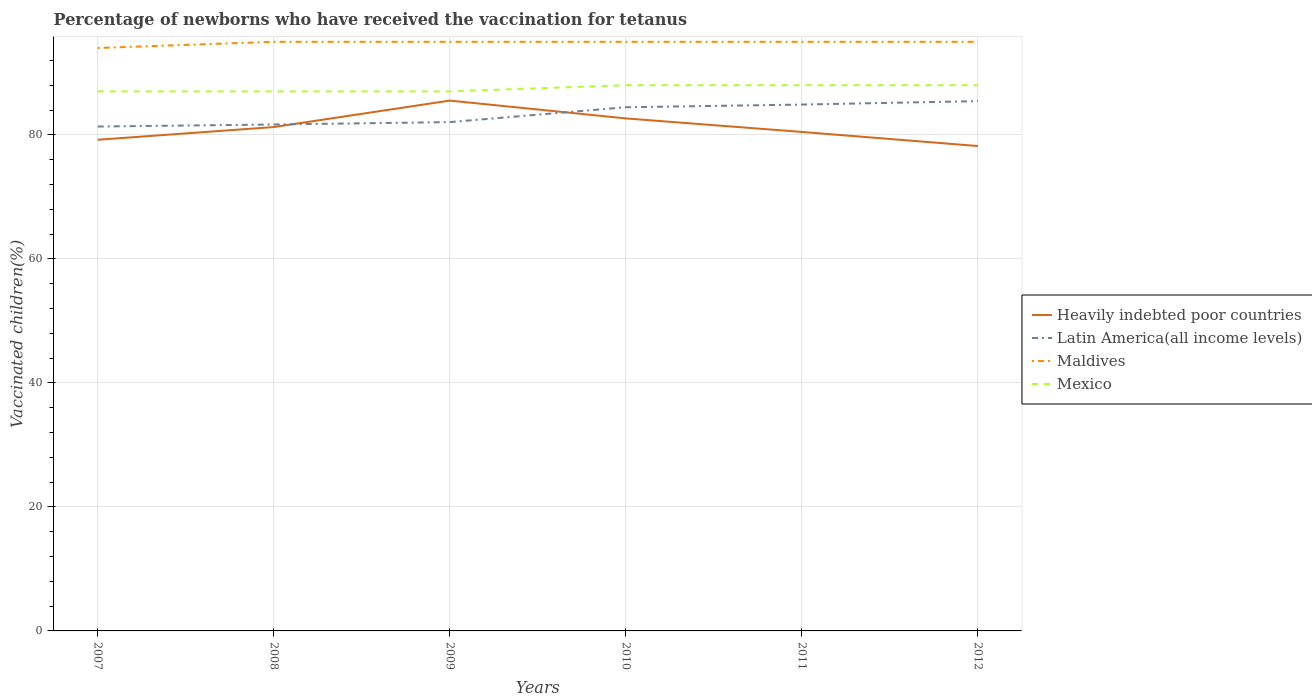Is the number of lines equal to the number of legend labels?
Provide a succinct answer. Yes. Across all years, what is the maximum percentage of vaccinated children in Latin America(all income levels)?
Your answer should be very brief. 81.33. In which year was the percentage of vaccinated children in Maldives maximum?
Make the answer very short. 2007. What is the total percentage of vaccinated children in Latin America(all income levels) in the graph?
Provide a succinct answer. -3.54. What is the difference between the highest and the second highest percentage of vaccinated children in Mexico?
Give a very brief answer. 1. How many lines are there?
Provide a short and direct response. 4. What is the difference between two consecutive major ticks on the Y-axis?
Make the answer very short. 20. Are the values on the major ticks of Y-axis written in scientific E-notation?
Ensure brevity in your answer.  No. Does the graph contain grids?
Offer a terse response. Yes. Where does the legend appear in the graph?
Ensure brevity in your answer.  Center right. How many legend labels are there?
Offer a terse response. 4. What is the title of the graph?
Make the answer very short. Percentage of newborns who have received the vaccination for tetanus. What is the label or title of the Y-axis?
Make the answer very short. Vaccinated children(%). What is the Vaccinated children(%) of Heavily indebted poor countries in 2007?
Your answer should be compact. 79.2. What is the Vaccinated children(%) in Latin America(all income levels) in 2007?
Ensure brevity in your answer.  81.33. What is the Vaccinated children(%) of Maldives in 2007?
Ensure brevity in your answer.  94. What is the Vaccinated children(%) in Mexico in 2007?
Your answer should be very brief. 87. What is the Vaccinated children(%) in Heavily indebted poor countries in 2008?
Your answer should be compact. 81.25. What is the Vaccinated children(%) of Latin America(all income levels) in 2008?
Make the answer very short. 81.66. What is the Vaccinated children(%) of Heavily indebted poor countries in 2009?
Give a very brief answer. 85.52. What is the Vaccinated children(%) in Latin America(all income levels) in 2009?
Your answer should be very brief. 82.05. What is the Vaccinated children(%) in Maldives in 2009?
Offer a very short reply. 95. What is the Vaccinated children(%) of Mexico in 2009?
Keep it short and to the point. 87. What is the Vaccinated children(%) in Heavily indebted poor countries in 2010?
Your answer should be compact. 82.64. What is the Vaccinated children(%) of Latin America(all income levels) in 2010?
Offer a very short reply. 84.45. What is the Vaccinated children(%) in Mexico in 2010?
Provide a succinct answer. 88. What is the Vaccinated children(%) of Heavily indebted poor countries in 2011?
Your answer should be very brief. 80.46. What is the Vaccinated children(%) in Latin America(all income levels) in 2011?
Offer a very short reply. 84.88. What is the Vaccinated children(%) in Mexico in 2011?
Your answer should be compact. 88. What is the Vaccinated children(%) in Heavily indebted poor countries in 2012?
Provide a short and direct response. 78.19. What is the Vaccinated children(%) in Latin America(all income levels) in 2012?
Your answer should be very brief. 85.43. What is the Vaccinated children(%) of Maldives in 2012?
Your response must be concise. 95. What is the Vaccinated children(%) of Mexico in 2012?
Ensure brevity in your answer.  88. Across all years, what is the maximum Vaccinated children(%) of Heavily indebted poor countries?
Ensure brevity in your answer.  85.52. Across all years, what is the maximum Vaccinated children(%) in Latin America(all income levels)?
Give a very brief answer. 85.43. Across all years, what is the maximum Vaccinated children(%) of Maldives?
Your answer should be compact. 95. Across all years, what is the maximum Vaccinated children(%) in Mexico?
Ensure brevity in your answer.  88. Across all years, what is the minimum Vaccinated children(%) in Heavily indebted poor countries?
Keep it short and to the point. 78.19. Across all years, what is the minimum Vaccinated children(%) in Latin America(all income levels)?
Offer a very short reply. 81.33. Across all years, what is the minimum Vaccinated children(%) of Maldives?
Make the answer very short. 94. What is the total Vaccinated children(%) of Heavily indebted poor countries in the graph?
Make the answer very short. 487.26. What is the total Vaccinated children(%) of Latin America(all income levels) in the graph?
Keep it short and to the point. 499.8. What is the total Vaccinated children(%) of Maldives in the graph?
Keep it short and to the point. 569. What is the total Vaccinated children(%) of Mexico in the graph?
Give a very brief answer. 525. What is the difference between the Vaccinated children(%) in Heavily indebted poor countries in 2007 and that in 2008?
Make the answer very short. -2.05. What is the difference between the Vaccinated children(%) of Latin America(all income levels) in 2007 and that in 2008?
Your response must be concise. -0.33. What is the difference between the Vaccinated children(%) in Maldives in 2007 and that in 2008?
Your answer should be compact. -1. What is the difference between the Vaccinated children(%) in Mexico in 2007 and that in 2008?
Give a very brief answer. 0. What is the difference between the Vaccinated children(%) of Heavily indebted poor countries in 2007 and that in 2009?
Offer a terse response. -6.32. What is the difference between the Vaccinated children(%) in Latin America(all income levels) in 2007 and that in 2009?
Give a very brief answer. -0.72. What is the difference between the Vaccinated children(%) in Heavily indebted poor countries in 2007 and that in 2010?
Keep it short and to the point. -3.44. What is the difference between the Vaccinated children(%) of Latin America(all income levels) in 2007 and that in 2010?
Give a very brief answer. -3.11. What is the difference between the Vaccinated children(%) of Maldives in 2007 and that in 2010?
Offer a terse response. -1. What is the difference between the Vaccinated children(%) of Heavily indebted poor countries in 2007 and that in 2011?
Your answer should be very brief. -1.26. What is the difference between the Vaccinated children(%) of Latin America(all income levels) in 2007 and that in 2011?
Your answer should be very brief. -3.54. What is the difference between the Vaccinated children(%) of Heavily indebted poor countries in 2007 and that in 2012?
Offer a very short reply. 1.01. What is the difference between the Vaccinated children(%) of Latin America(all income levels) in 2007 and that in 2012?
Make the answer very short. -4.1. What is the difference between the Vaccinated children(%) in Heavily indebted poor countries in 2008 and that in 2009?
Provide a succinct answer. -4.27. What is the difference between the Vaccinated children(%) of Latin America(all income levels) in 2008 and that in 2009?
Ensure brevity in your answer.  -0.39. What is the difference between the Vaccinated children(%) in Heavily indebted poor countries in 2008 and that in 2010?
Your response must be concise. -1.39. What is the difference between the Vaccinated children(%) in Latin America(all income levels) in 2008 and that in 2010?
Your answer should be very brief. -2.78. What is the difference between the Vaccinated children(%) of Mexico in 2008 and that in 2010?
Offer a very short reply. -1. What is the difference between the Vaccinated children(%) of Heavily indebted poor countries in 2008 and that in 2011?
Your answer should be very brief. 0.79. What is the difference between the Vaccinated children(%) in Latin America(all income levels) in 2008 and that in 2011?
Your answer should be compact. -3.21. What is the difference between the Vaccinated children(%) in Maldives in 2008 and that in 2011?
Your response must be concise. 0. What is the difference between the Vaccinated children(%) of Mexico in 2008 and that in 2011?
Your answer should be compact. -1. What is the difference between the Vaccinated children(%) of Heavily indebted poor countries in 2008 and that in 2012?
Provide a succinct answer. 3.06. What is the difference between the Vaccinated children(%) in Latin America(all income levels) in 2008 and that in 2012?
Make the answer very short. -3.77. What is the difference between the Vaccinated children(%) of Maldives in 2008 and that in 2012?
Keep it short and to the point. 0. What is the difference between the Vaccinated children(%) in Mexico in 2008 and that in 2012?
Keep it short and to the point. -1. What is the difference between the Vaccinated children(%) of Heavily indebted poor countries in 2009 and that in 2010?
Your answer should be compact. 2.87. What is the difference between the Vaccinated children(%) of Latin America(all income levels) in 2009 and that in 2010?
Offer a terse response. -2.4. What is the difference between the Vaccinated children(%) in Maldives in 2009 and that in 2010?
Offer a very short reply. 0. What is the difference between the Vaccinated children(%) of Mexico in 2009 and that in 2010?
Offer a terse response. -1. What is the difference between the Vaccinated children(%) in Heavily indebted poor countries in 2009 and that in 2011?
Your answer should be very brief. 5.06. What is the difference between the Vaccinated children(%) in Latin America(all income levels) in 2009 and that in 2011?
Provide a succinct answer. -2.83. What is the difference between the Vaccinated children(%) in Mexico in 2009 and that in 2011?
Give a very brief answer. -1. What is the difference between the Vaccinated children(%) of Heavily indebted poor countries in 2009 and that in 2012?
Provide a short and direct response. 7.33. What is the difference between the Vaccinated children(%) in Latin America(all income levels) in 2009 and that in 2012?
Your response must be concise. -3.38. What is the difference between the Vaccinated children(%) in Maldives in 2009 and that in 2012?
Offer a terse response. 0. What is the difference between the Vaccinated children(%) in Mexico in 2009 and that in 2012?
Give a very brief answer. -1. What is the difference between the Vaccinated children(%) of Heavily indebted poor countries in 2010 and that in 2011?
Your answer should be very brief. 2.18. What is the difference between the Vaccinated children(%) of Latin America(all income levels) in 2010 and that in 2011?
Offer a terse response. -0.43. What is the difference between the Vaccinated children(%) of Maldives in 2010 and that in 2011?
Offer a very short reply. 0. What is the difference between the Vaccinated children(%) in Mexico in 2010 and that in 2011?
Your answer should be very brief. 0. What is the difference between the Vaccinated children(%) of Heavily indebted poor countries in 2010 and that in 2012?
Offer a very short reply. 4.45. What is the difference between the Vaccinated children(%) of Latin America(all income levels) in 2010 and that in 2012?
Provide a short and direct response. -0.98. What is the difference between the Vaccinated children(%) in Maldives in 2010 and that in 2012?
Make the answer very short. 0. What is the difference between the Vaccinated children(%) in Mexico in 2010 and that in 2012?
Your answer should be very brief. 0. What is the difference between the Vaccinated children(%) of Heavily indebted poor countries in 2011 and that in 2012?
Keep it short and to the point. 2.27. What is the difference between the Vaccinated children(%) of Latin America(all income levels) in 2011 and that in 2012?
Provide a short and direct response. -0.55. What is the difference between the Vaccinated children(%) in Mexico in 2011 and that in 2012?
Provide a short and direct response. 0. What is the difference between the Vaccinated children(%) of Heavily indebted poor countries in 2007 and the Vaccinated children(%) of Latin America(all income levels) in 2008?
Your answer should be compact. -2.46. What is the difference between the Vaccinated children(%) of Heavily indebted poor countries in 2007 and the Vaccinated children(%) of Maldives in 2008?
Keep it short and to the point. -15.8. What is the difference between the Vaccinated children(%) of Heavily indebted poor countries in 2007 and the Vaccinated children(%) of Mexico in 2008?
Ensure brevity in your answer.  -7.8. What is the difference between the Vaccinated children(%) in Latin America(all income levels) in 2007 and the Vaccinated children(%) in Maldives in 2008?
Make the answer very short. -13.67. What is the difference between the Vaccinated children(%) of Latin America(all income levels) in 2007 and the Vaccinated children(%) of Mexico in 2008?
Make the answer very short. -5.67. What is the difference between the Vaccinated children(%) in Heavily indebted poor countries in 2007 and the Vaccinated children(%) in Latin America(all income levels) in 2009?
Give a very brief answer. -2.85. What is the difference between the Vaccinated children(%) in Heavily indebted poor countries in 2007 and the Vaccinated children(%) in Maldives in 2009?
Ensure brevity in your answer.  -15.8. What is the difference between the Vaccinated children(%) in Heavily indebted poor countries in 2007 and the Vaccinated children(%) in Mexico in 2009?
Make the answer very short. -7.8. What is the difference between the Vaccinated children(%) of Latin America(all income levels) in 2007 and the Vaccinated children(%) of Maldives in 2009?
Your response must be concise. -13.67. What is the difference between the Vaccinated children(%) in Latin America(all income levels) in 2007 and the Vaccinated children(%) in Mexico in 2009?
Your answer should be very brief. -5.67. What is the difference between the Vaccinated children(%) of Maldives in 2007 and the Vaccinated children(%) of Mexico in 2009?
Offer a terse response. 7. What is the difference between the Vaccinated children(%) of Heavily indebted poor countries in 2007 and the Vaccinated children(%) of Latin America(all income levels) in 2010?
Keep it short and to the point. -5.25. What is the difference between the Vaccinated children(%) of Heavily indebted poor countries in 2007 and the Vaccinated children(%) of Maldives in 2010?
Keep it short and to the point. -15.8. What is the difference between the Vaccinated children(%) in Heavily indebted poor countries in 2007 and the Vaccinated children(%) in Mexico in 2010?
Provide a succinct answer. -8.8. What is the difference between the Vaccinated children(%) of Latin America(all income levels) in 2007 and the Vaccinated children(%) of Maldives in 2010?
Your answer should be very brief. -13.67. What is the difference between the Vaccinated children(%) of Latin America(all income levels) in 2007 and the Vaccinated children(%) of Mexico in 2010?
Offer a very short reply. -6.67. What is the difference between the Vaccinated children(%) in Heavily indebted poor countries in 2007 and the Vaccinated children(%) in Latin America(all income levels) in 2011?
Provide a succinct answer. -5.68. What is the difference between the Vaccinated children(%) of Heavily indebted poor countries in 2007 and the Vaccinated children(%) of Maldives in 2011?
Ensure brevity in your answer.  -15.8. What is the difference between the Vaccinated children(%) in Heavily indebted poor countries in 2007 and the Vaccinated children(%) in Mexico in 2011?
Make the answer very short. -8.8. What is the difference between the Vaccinated children(%) in Latin America(all income levels) in 2007 and the Vaccinated children(%) in Maldives in 2011?
Ensure brevity in your answer.  -13.67. What is the difference between the Vaccinated children(%) of Latin America(all income levels) in 2007 and the Vaccinated children(%) of Mexico in 2011?
Offer a terse response. -6.67. What is the difference between the Vaccinated children(%) of Heavily indebted poor countries in 2007 and the Vaccinated children(%) of Latin America(all income levels) in 2012?
Give a very brief answer. -6.23. What is the difference between the Vaccinated children(%) in Heavily indebted poor countries in 2007 and the Vaccinated children(%) in Maldives in 2012?
Your answer should be very brief. -15.8. What is the difference between the Vaccinated children(%) of Heavily indebted poor countries in 2007 and the Vaccinated children(%) of Mexico in 2012?
Your response must be concise. -8.8. What is the difference between the Vaccinated children(%) of Latin America(all income levels) in 2007 and the Vaccinated children(%) of Maldives in 2012?
Make the answer very short. -13.67. What is the difference between the Vaccinated children(%) of Latin America(all income levels) in 2007 and the Vaccinated children(%) of Mexico in 2012?
Provide a short and direct response. -6.67. What is the difference between the Vaccinated children(%) in Heavily indebted poor countries in 2008 and the Vaccinated children(%) in Latin America(all income levels) in 2009?
Provide a short and direct response. -0.8. What is the difference between the Vaccinated children(%) in Heavily indebted poor countries in 2008 and the Vaccinated children(%) in Maldives in 2009?
Offer a very short reply. -13.75. What is the difference between the Vaccinated children(%) of Heavily indebted poor countries in 2008 and the Vaccinated children(%) of Mexico in 2009?
Offer a very short reply. -5.75. What is the difference between the Vaccinated children(%) of Latin America(all income levels) in 2008 and the Vaccinated children(%) of Maldives in 2009?
Give a very brief answer. -13.34. What is the difference between the Vaccinated children(%) of Latin America(all income levels) in 2008 and the Vaccinated children(%) of Mexico in 2009?
Provide a short and direct response. -5.34. What is the difference between the Vaccinated children(%) in Heavily indebted poor countries in 2008 and the Vaccinated children(%) in Latin America(all income levels) in 2010?
Offer a terse response. -3.2. What is the difference between the Vaccinated children(%) of Heavily indebted poor countries in 2008 and the Vaccinated children(%) of Maldives in 2010?
Keep it short and to the point. -13.75. What is the difference between the Vaccinated children(%) of Heavily indebted poor countries in 2008 and the Vaccinated children(%) of Mexico in 2010?
Your answer should be compact. -6.75. What is the difference between the Vaccinated children(%) in Latin America(all income levels) in 2008 and the Vaccinated children(%) in Maldives in 2010?
Provide a succinct answer. -13.34. What is the difference between the Vaccinated children(%) of Latin America(all income levels) in 2008 and the Vaccinated children(%) of Mexico in 2010?
Offer a terse response. -6.34. What is the difference between the Vaccinated children(%) in Heavily indebted poor countries in 2008 and the Vaccinated children(%) in Latin America(all income levels) in 2011?
Offer a very short reply. -3.63. What is the difference between the Vaccinated children(%) in Heavily indebted poor countries in 2008 and the Vaccinated children(%) in Maldives in 2011?
Provide a short and direct response. -13.75. What is the difference between the Vaccinated children(%) of Heavily indebted poor countries in 2008 and the Vaccinated children(%) of Mexico in 2011?
Your answer should be very brief. -6.75. What is the difference between the Vaccinated children(%) of Latin America(all income levels) in 2008 and the Vaccinated children(%) of Maldives in 2011?
Offer a terse response. -13.34. What is the difference between the Vaccinated children(%) of Latin America(all income levels) in 2008 and the Vaccinated children(%) of Mexico in 2011?
Ensure brevity in your answer.  -6.34. What is the difference between the Vaccinated children(%) in Heavily indebted poor countries in 2008 and the Vaccinated children(%) in Latin America(all income levels) in 2012?
Make the answer very short. -4.18. What is the difference between the Vaccinated children(%) of Heavily indebted poor countries in 2008 and the Vaccinated children(%) of Maldives in 2012?
Offer a terse response. -13.75. What is the difference between the Vaccinated children(%) in Heavily indebted poor countries in 2008 and the Vaccinated children(%) in Mexico in 2012?
Keep it short and to the point. -6.75. What is the difference between the Vaccinated children(%) of Latin America(all income levels) in 2008 and the Vaccinated children(%) of Maldives in 2012?
Keep it short and to the point. -13.34. What is the difference between the Vaccinated children(%) in Latin America(all income levels) in 2008 and the Vaccinated children(%) in Mexico in 2012?
Ensure brevity in your answer.  -6.34. What is the difference between the Vaccinated children(%) of Heavily indebted poor countries in 2009 and the Vaccinated children(%) of Latin America(all income levels) in 2010?
Your response must be concise. 1.07. What is the difference between the Vaccinated children(%) of Heavily indebted poor countries in 2009 and the Vaccinated children(%) of Maldives in 2010?
Give a very brief answer. -9.48. What is the difference between the Vaccinated children(%) in Heavily indebted poor countries in 2009 and the Vaccinated children(%) in Mexico in 2010?
Offer a terse response. -2.48. What is the difference between the Vaccinated children(%) of Latin America(all income levels) in 2009 and the Vaccinated children(%) of Maldives in 2010?
Keep it short and to the point. -12.95. What is the difference between the Vaccinated children(%) in Latin America(all income levels) in 2009 and the Vaccinated children(%) in Mexico in 2010?
Ensure brevity in your answer.  -5.95. What is the difference between the Vaccinated children(%) of Heavily indebted poor countries in 2009 and the Vaccinated children(%) of Latin America(all income levels) in 2011?
Offer a very short reply. 0.64. What is the difference between the Vaccinated children(%) of Heavily indebted poor countries in 2009 and the Vaccinated children(%) of Maldives in 2011?
Offer a very short reply. -9.48. What is the difference between the Vaccinated children(%) in Heavily indebted poor countries in 2009 and the Vaccinated children(%) in Mexico in 2011?
Provide a succinct answer. -2.48. What is the difference between the Vaccinated children(%) of Latin America(all income levels) in 2009 and the Vaccinated children(%) of Maldives in 2011?
Your answer should be very brief. -12.95. What is the difference between the Vaccinated children(%) of Latin America(all income levels) in 2009 and the Vaccinated children(%) of Mexico in 2011?
Offer a very short reply. -5.95. What is the difference between the Vaccinated children(%) of Maldives in 2009 and the Vaccinated children(%) of Mexico in 2011?
Make the answer very short. 7. What is the difference between the Vaccinated children(%) of Heavily indebted poor countries in 2009 and the Vaccinated children(%) of Latin America(all income levels) in 2012?
Give a very brief answer. 0.09. What is the difference between the Vaccinated children(%) in Heavily indebted poor countries in 2009 and the Vaccinated children(%) in Maldives in 2012?
Provide a short and direct response. -9.48. What is the difference between the Vaccinated children(%) in Heavily indebted poor countries in 2009 and the Vaccinated children(%) in Mexico in 2012?
Provide a short and direct response. -2.48. What is the difference between the Vaccinated children(%) of Latin America(all income levels) in 2009 and the Vaccinated children(%) of Maldives in 2012?
Offer a very short reply. -12.95. What is the difference between the Vaccinated children(%) of Latin America(all income levels) in 2009 and the Vaccinated children(%) of Mexico in 2012?
Give a very brief answer. -5.95. What is the difference between the Vaccinated children(%) of Heavily indebted poor countries in 2010 and the Vaccinated children(%) of Latin America(all income levels) in 2011?
Make the answer very short. -2.23. What is the difference between the Vaccinated children(%) of Heavily indebted poor countries in 2010 and the Vaccinated children(%) of Maldives in 2011?
Offer a terse response. -12.36. What is the difference between the Vaccinated children(%) of Heavily indebted poor countries in 2010 and the Vaccinated children(%) of Mexico in 2011?
Ensure brevity in your answer.  -5.36. What is the difference between the Vaccinated children(%) in Latin America(all income levels) in 2010 and the Vaccinated children(%) in Maldives in 2011?
Offer a terse response. -10.55. What is the difference between the Vaccinated children(%) in Latin America(all income levels) in 2010 and the Vaccinated children(%) in Mexico in 2011?
Provide a short and direct response. -3.55. What is the difference between the Vaccinated children(%) in Maldives in 2010 and the Vaccinated children(%) in Mexico in 2011?
Make the answer very short. 7. What is the difference between the Vaccinated children(%) in Heavily indebted poor countries in 2010 and the Vaccinated children(%) in Latin America(all income levels) in 2012?
Your response must be concise. -2.79. What is the difference between the Vaccinated children(%) of Heavily indebted poor countries in 2010 and the Vaccinated children(%) of Maldives in 2012?
Your answer should be very brief. -12.36. What is the difference between the Vaccinated children(%) in Heavily indebted poor countries in 2010 and the Vaccinated children(%) in Mexico in 2012?
Make the answer very short. -5.36. What is the difference between the Vaccinated children(%) of Latin America(all income levels) in 2010 and the Vaccinated children(%) of Maldives in 2012?
Keep it short and to the point. -10.55. What is the difference between the Vaccinated children(%) of Latin America(all income levels) in 2010 and the Vaccinated children(%) of Mexico in 2012?
Ensure brevity in your answer.  -3.55. What is the difference between the Vaccinated children(%) in Heavily indebted poor countries in 2011 and the Vaccinated children(%) in Latin America(all income levels) in 2012?
Offer a very short reply. -4.97. What is the difference between the Vaccinated children(%) in Heavily indebted poor countries in 2011 and the Vaccinated children(%) in Maldives in 2012?
Offer a terse response. -14.54. What is the difference between the Vaccinated children(%) of Heavily indebted poor countries in 2011 and the Vaccinated children(%) of Mexico in 2012?
Keep it short and to the point. -7.54. What is the difference between the Vaccinated children(%) of Latin America(all income levels) in 2011 and the Vaccinated children(%) of Maldives in 2012?
Offer a terse response. -10.12. What is the difference between the Vaccinated children(%) of Latin America(all income levels) in 2011 and the Vaccinated children(%) of Mexico in 2012?
Give a very brief answer. -3.12. What is the difference between the Vaccinated children(%) of Maldives in 2011 and the Vaccinated children(%) of Mexico in 2012?
Make the answer very short. 7. What is the average Vaccinated children(%) in Heavily indebted poor countries per year?
Ensure brevity in your answer.  81.21. What is the average Vaccinated children(%) in Latin America(all income levels) per year?
Offer a very short reply. 83.3. What is the average Vaccinated children(%) in Maldives per year?
Offer a very short reply. 94.83. What is the average Vaccinated children(%) of Mexico per year?
Keep it short and to the point. 87.5. In the year 2007, what is the difference between the Vaccinated children(%) of Heavily indebted poor countries and Vaccinated children(%) of Latin America(all income levels)?
Provide a short and direct response. -2.13. In the year 2007, what is the difference between the Vaccinated children(%) of Heavily indebted poor countries and Vaccinated children(%) of Maldives?
Give a very brief answer. -14.8. In the year 2007, what is the difference between the Vaccinated children(%) in Heavily indebted poor countries and Vaccinated children(%) in Mexico?
Offer a terse response. -7.8. In the year 2007, what is the difference between the Vaccinated children(%) of Latin America(all income levels) and Vaccinated children(%) of Maldives?
Your answer should be very brief. -12.67. In the year 2007, what is the difference between the Vaccinated children(%) in Latin America(all income levels) and Vaccinated children(%) in Mexico?
Ensure brevity in your answer.  -5.67. In the year 2007, what is the difference between the Vaccinated children(%) in Maldives and Vaccinated children(%) in Mexico?
Your answer should be compact. 7. In the year 2008, what is the difference between the Vaccinated children(%) of Heavily indebted poor countries and Vaccinated children(%) of Latin America(all income levels)?
Offer a terse response. -0.41. In the year 2008, what is the difference between the Vaccinated children(%) of Heavily indebted poor countries and Vaccinated children(%) of Maldives?
Your answer should be compact. -13.75. In the year 2008, what is the difference between the Vaccinated children(%) in Heavily indebted poor countries and Vaccinated children(%) in Mexico?
Your response must be concise. -5.75. In the year 2008, what is the difference between the Vaccinated children(%) of Latin America(all income levels) and Vaccinated children(%) of Maldives?
Provide a succinct answer. -13.34. In the year 2008, what is the difference between the Vaccinated children(%) in Latin America(all income levels) and Vaccinated children(%) in Mexico?
Your answer should be compact. -5.34. In the year 2008, what is the difference between the Vaccinated children(%) of Maldives and Vaccinated children(%) of Mexico?
Keep it short and to the point. 8. In the year 2009, what is the difference between the Vaccinated children(%) of Heavily indebted poor countries and Vaccinated children(%) of Latin America(all income levels)?
Provide a short and direct response. 3.47. In the year 2009, what is the difference between the Vaccinated children(%) in Heavily indebted poor countries and Vaccinated children(%) in Maldives?
Offer a very short reply. -9.48. In the year 2009, what is the difference between the Vaccinated children(%) of Heavily indebted poor countries and Vaccinated children(%) of Mexico?
Keep it short and to the point. -1.48. In the year 2009, what is the difference between the Vaccinated children(%) of Latin America(all income levels) and Vaccinated children(%) of Maldives?
Offer a terse response. -12.95. In the year 2009, what is the difference between the Vaccinated children(%) in Latin America(all income levels) and Vaccinated children(%) in Mexico?
Keep it short and to the point. -4.95. In the year 2010, what is the difference between the Vaccinated children(%) of Heavily indebted poor countries and Vaccinated children(%) of Latin America(all income levels)?
Make the answer very short. -1.8. In the year 2010, what is the difference between the Vaccinated children(%) of Heavily indebted poor countries and Vaccinated children(%) of Maldives?
Offer a very short reply. -12.36. In the year 2010, what is the difference between the Vaccinated children(%) of Heavily indebted poor countries and Vaccinated children(%) of Mexico?
Your answer should be compact. -5.36. In the year 2010, what is the difference between the Vaccinated children(%) of Latin America(all income levels) and Vaccinated children(%) of Maldives?
Ensure brevity in your answer.  -10.55. In the year 2010, what is the difference between the Vaccinated children(%) in Latin America(all income levels) and Vaccinated children(%) in Mexico?
Offer a very short reply. -3.55. In the year 2010, what is the difference between the Vaccinated children(%) of Maldives and Vaccinated children(%) of Mexico?
Your response must be concise. 7. In the year 2011, what is the difference between the Vaccinated children(%) of Heavily indebted poor countries and Vaccinated children(%) of Latin America(all income levels)?
Your answer should be compact. -4.41. In the year 2011, what is the difference between the Vaccinated children(%) in Heavily indebted poor countries and Vaccinated children(%) in Maldives?
Offer a very short reply. -14.54. In the year 2011, what is the difference between the Vaccinated children(%) of Heavily indebted poor countries and Vaccinated children(%) of Mexico?
Keep it short and to the point. -7.54. In the year 2011, what is the difference between the Vaccinated children(%) of Latin America(all income levels) and Vaccinated children(%) of Maldives?
Offer a very short reply. -10.12. In the year 2011, what is the difference between the Vaccinated children(%) in Latin America(all income levels) and Vaccinated children(%) in Mexico?
Ensure brevity in your answer.  -3.12. In the year 2011, what is the difference between the Vaccinated children(%) in Maldives and Vaccinated children(%) in Mexico?
Offer a terse response. 7. In the year 2012, what is the difference between the Vaccinated children(%) in Heavily indebted poor countries and Vaccinated children(%) in Latin America(all income levels)?
Keep it short and to the point. -7.24. In the year 2012, what is the difference between the Vaccinated children(%) of Heavily indebted poor countries and Vaccinated children(%) of Maldives?
Provide a short and direct response. -16.81. In the year 2012, what is the difference between the Vaccinated children(%) in Heavily indebted poor countries and Vaccinated children(%) in Mexico?
Your response must be concise. -9.81. In the year 2012, what is the difference between the Vaccinated children(%) of Latin America(all income levels) and Vaccinated children(%) of Maldives?
Give a very brief answer. -9.57. In the year 2012, what is the difference between the Vaccinated children(%) of Latin America(all income levels) and Vaccinated children(%) of Mexico?
Your response must be concise. -2.57. What is the ratio of the Vaccinated children(%) in Heavily indebted poor countries in 2007 to that in 2008?
Your answer should be very brief. 0.97. What is the ratio of the Vaccinated children(%) in Maldives in 2007 to that in 2008?
Offer a terse response. 0.99. What is the ratio of the Vaccinated children(%) of Mexico in 2007 to that in 2008?
Provide a short and direct response. 1. What is the ratio of the Vaccinated children(%) in Heavily indebted poor countries in 2007 to that in 2009?
Your answer should be very brief. 0.93. What is the ratio of the Vaccinated children(%) in Maldives in 2007 to that in 2009?
Provide a short and direct response. 0.99. What is the ratio of the Vaccinated children(%) of Latin America(all income levels) in 2007 to that in 2010?
Provide a short and direct response. 0.96. What is the ratio of the Vaccinated children(%) in Heavily indebted poor countries in 2007 to that in 2011?
Provide a succinct answer. 0.98. What is the ratio of the Vaccinated children(%) of Mexico in 2007 to that in 2011?
Make the answer very short. 0.99. What is the ratio of the Vaccinated children(%) in Heavily indebted poor countries in 2007 to that in 2012?
Provide a succinct answer. 1.01. What is the ratio of the Vaccinated children(%) of Maldives in 2007 to that in 2012?
Offer a terse response. 0.99. What is the ratio of the Vaccinated children(%) in Mexico in 2007 to that in 2012?
Keep it short and to the point. 0.99. What is the ratio of the Vaccinated children(%) in Heavily indebted poor countries in 2008 to that in 2009?
Your answer should be compact. 0.95. What is the ratio of the Vaccinated children(%) of Maldives in 2008 to that in 2009?
Your answer should be very brief. 1. What is the ratio of the Vaccinated children(%) in Mexico in 2008 to that in 2009?
Ensure brevity in your answer.  1. What is the ratio of the Vaccinated children(%) in Heavily indebted poor countries in 2008 to that in 2010?
Your answer should be very brief. 0.98. What is the ratio of the Vaccinated children(%) of Maldives in 2008 to that in 2010?
Ensure brevity in your answer.  1. What is the ratio of the Vaccinated children(%) in Heavily indebted poor countries in 2008 to that in 2011?
Keep it short and to the point. 1.01. What is the ratio of the Vaccinated children(%) in Latin America(all income levels) in 2008 to that in 2011?
Offer a terse response. 0.96. What is the ratio of the Vaccinated children(%) in Heavily indebted poor countries in 2008 to that in 2012?
Provide a succinct answer. 1.04. What is the ratio of the Vaccinated children(%) of Latin America(all income levels) in 2008 to that in 2012?
Ensure brevity in your answer.  0.96. What is the ratio of the Vaccinated children(%) in Heavily indebted poor countries in 2009 to that in 2010?
Your answer should be very brief. 1.03. What is the ratio of the Vaccinated children(%) in Latin America(all income levels) in 2009 to that in 2010?
Provide a short and direct response. 0.97. What is the ratio of the Vaccinated children(%) of Maldives in 2009 to that in 2010?
Provide a succinct answer. 1. What is the ratio of the Vaccinated children(%) in Mexico in 2009 to that in 2010?
Offer a terse response. 0.99. What is the ratio of the Vaccinated children(%) in Heavily indebted poor countries in 2009 to that in 2011?
Ensure brevity in your answer.  1.06. What is the ratio of the Vaccinated children(%) of Latin America(all income levels) in 2009 to that in 2011?
Ensure brevity in your answer.  0.97. What is the ratio of the Vaccinated children(%) in Maldives in 2009 to that in 2011?
Make the answer very short. 1. What is the ratio of the Vaccinated children(%) in Mexico in 2009 to that in 2011?
Make the answer very short. 0.99. What is the ratio of the Vaccinated children(%) of Heavily indebted poor countries in 2009 to that in 2012?
Provide a short and direct response. 1.09. What is the ratio of the Vaccinated children(%) in Latin America(all income levels) in 2009 to that in 2012?
Ensure brevity in your answer.  0.96. What is the ratio of the Vaccinated children(%) in Maldives in 2009 to that in 2012?
Provide a short and direct response. 1. What is the ratio of the Vaccinated children(%) of Heavily indebted poor countries in 2010 to that in 2011?
Ensure brevity in your answer.  1.03. What is the ratio of the Vaccinated children(%) in Maldives in 2010 to that in 2011?
Provide a short and direct response. 1. What is the ratio of the Vaccinated children(%) in Mexico in 2010 to that in 2011?
Make the answer very short. 1. What is the ratio of the Vaccinated children(%) of Heavily indebted poor countries in 2010 to that in 2012?
Offer a very short reply. 1.06. What is the ratio of the Vaccinated children(%) in Mexico in 2010 to that in 2012?
Ensure brevity in your answer.  1. What is the ratio of the Vaccinated children(%) in Heavily indebted poor countries in 2011 to that in 2012?
Keep it short and to the point. 1.03. What is the ratio of the Vaccinated children(%) of Latin America(all income levels) in 2011 to that in 2012?
Ensure brevity in your answer.  0.99. What is the ratio of the Vaccinated children(%) of Mexico in 2011 to that in 2012?
Offer a very short reply. 1. What is the difference between the highest and the second highest Vaccinated children(%) in Heavily indebted poor countries?
Offer a terse response. 2.87. What is the difference between the highest and the second highest Vaccinated children(%) in Latin America(all income levels)?
Ensure brevity in your answer.  0.55. What is the difference between the highest and the lowest Vaccinated children(%) in Heavily indebted poor countries?
Provide a succinct answer. 7.33. What is the difference between the highest and the lowest Vaccinated children(%) in Latin America(all income levels)?
Offer a terse response. 4.1. What is the difference between the highest and the lowest Vaccinated children(%) in Maldives?
Provide a short and direct response. 1. 